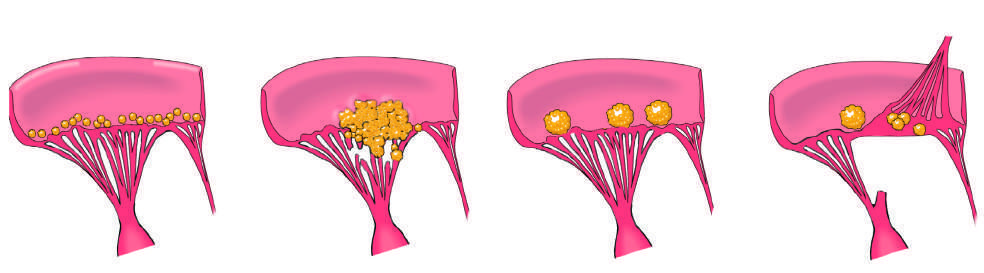what is characterized by large, irregular, often destructive masses that can extend from valve leaflets onto adjacent structures e.g., chordae or myocardium?
Answer the question using a single word or phrase. Infective endocarditis (ie) 